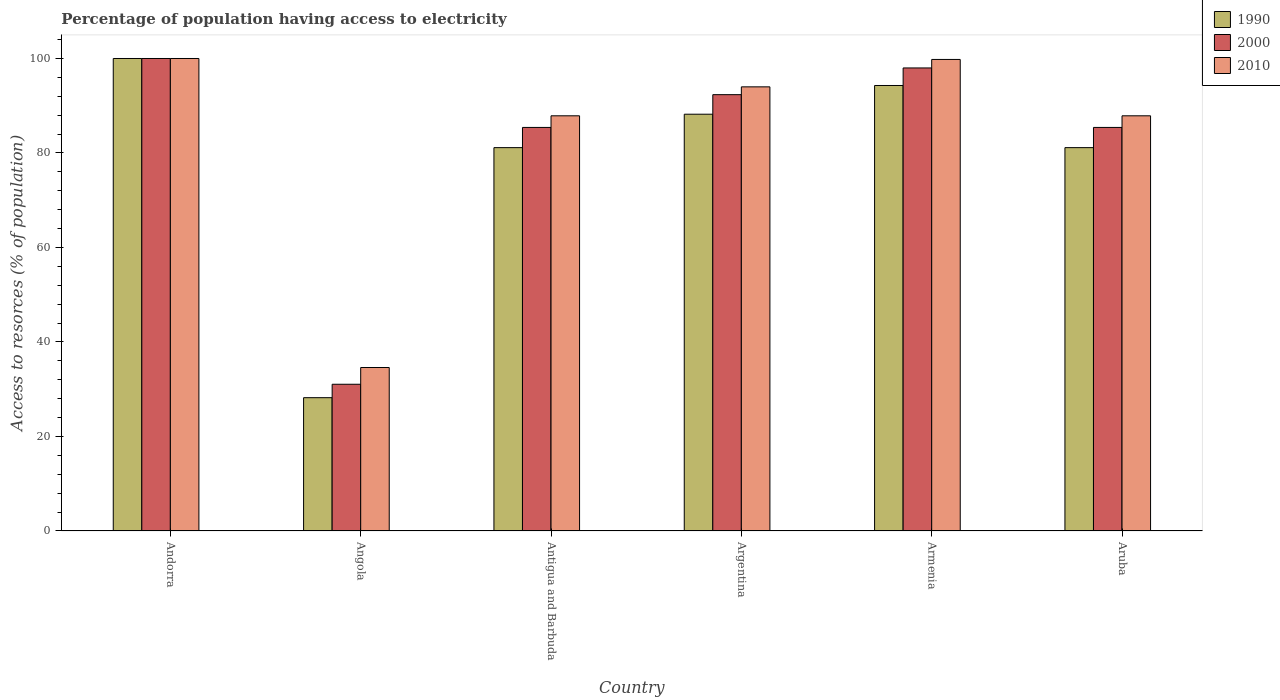How many different coloured bars are there?
Make the answer very short. 3. Are the number of bars per tick equal to the number of legend labels?
Offer a very short reply. Yes. Are the number of bars on each tick of the X-axis equal?
Provide a short and direct response. Yes. How many bars are there on the 2nd tick from the left?
Provide a short and direct response. 3. What is the label of the 5th group of bars from the left?
Give a very brief answer. Armenia. In how many cases, is the number of bars for a given country not equal to the number of legend labels?
Provide a short and direct response. 0. What is the percentage of population having access to electricity in 2000 in Aruba?
Your answer should be compact. 85.41. Across all countries, what is the minimum percentage of population having access to electricity in 2000?
Make the answer very short. 31.06. In which country was the percentage of population having access to electricity in 1990 maximum?
Provide a succinct answer. Andorra. In which country was the percentage of population having access to electricity in 2010 minimum?
Your answer should be compact. Angola. What is the total percentage of population having access to electricity in 2010 in the graph?
Keep it short and to the point. 504.15. What is the difference between the percentage of population having access to electricity in 2010 in Angola and that in Aruba?
Provide a succinct answer. -53.27. What is the difference between the percentage of population having access to electricity in 2010 in Andorra and the percentage of population having access to electricity in 1990 in Argentina?
Offer a very short reply. 11.79. What is the average percentage of population having access to electricity in 2000 per country?
Give a very brief answer. 82.04. What is the difference between the percentage of population having access to electricity of/in 2000 and percentage of population having access to electricity of/in 1990 in Argentina?
Your answer should be very brief. 4.14. What is the ratio of the percentage of population having access to electricity in 2000 in Armenia to that in Aruba?
Provide a succinct answer. 1.15. Is the percentage of population having access to electricity in 1990 in Angola less than that in Argentina?
Keep it short and to the point. Yes. Is the difference between the percentage of population having access to electricity in 2000 in Antigua and Barbuda and Aruba greater than the difference between the percentage of population having access to electricity in 1990 in Antigua and Barbuda and Aruba?
Give a very brief answer. No. What is the difference between the highest and the second highest percentage of population having access to electricity in 1990?
Offer a terse response. -11.79. What is the difference between the highest and the lowest percentage of population having access to electricity in 1990?
Keep it short and to the point. 71.78. What does the 1st bar from the left in Aruba represents?
Give a very brief answer. 1990. What does the 1st bar from the right in Argentina represents?
Keep it short and to the point. 2010. Is it the case that in every country, the sum of the percentage of population having access to electricity in 2000 and percentage of population having access to electricity in 1990 is greater than the percentage of population having access to electricity in 2010?
Provide a short and direct response. Yes. How many bars are there?
Give a very brief answer. 18. Does the graph contain any zero values?
Your response must be concise. No. Does the graph contain grids?
Provide a short and direct response. No. How many legend labels are there?
Offer a very short reply. 3. How are the legend labels stacked?
Give a very brief answer. Vertical. What is the title of the graph?
Provide a short and direct response. Percentage of population having access to electricity. What is the label or title of the Y-axis?
Offer a very short reply. Access to resorces (% of population). What is the Access to resorces (% of population) of 1990 in Angola?
Offer a very short reply. 28.22. What is the Access to resorces (% of population) of 2000 in Angola?
Provide a succinct answer. 31.06. What is the Access to resorces (% of population) in 2010 in Angola?
Ensure brevity in your answer.  34.6. What is the Access to resorces (% of population) of 1990 in Antigua and Barbuda?
Provide a succinct answer. 81.14. What is the Access to resorces (% of population) in 2000 in Antigua and Barbuda?
Provide a short and direct response. 85.41. What is the Access to resorces (% of population) of 2010 in Antigua and Barbuda?
Your response must be concise. 87.87. What is the Access to resorces (% of population) of 1990 in Argentina?
Provide a short and direct response. 88.21. What is the Access to resorces (% of population) in 2000 in Argentina?
Make the answer very short. 92.35. What is the Access to resorces (% of population) of 2010 in Argentina?
Your answer should be compact. 94. What is the Access to resorces (% of population) of 1990 in Armenia?
Make the answer very short. 94.29. What is the Access to resorces (% of population) in 2000 in Armenia?
Make the answer very short. 98. What is the Access to resorces (% of population) of 2010 in Armenia?
Provide a short and direct response. 99.8. What is the Access to resorces (% of population) of 1990 in Aruba?
Your answer should be compact. 81.14. What is the Access to resorces (% of population) of 2000 in Aruba?
Make the answer very short. 85.41. What is the Access to resorces (% of population) of 2010 in Aruba?
Provide a succinct answer. 87.87. Across all countries, what is the maximum Access to resorces (% of population) in 2000?
Offer a very short reply. 100. Across all countries, what is the minimum Access to resorces (% of population) in 1990?
Provide a short and direct response. 28.22. Across all countries, what is the minimum Access to resorces (% of population) in 2000?
Your answer should be very brief. 31.06. Across all countries, what is the minimum Access to resorces (% of population) of 2010?
Your response must be concise. 34.6. What is the total Access to resorces (% of population) in 1990 in the graph?
Give a very brief answer. 472.98. What is the total Access to resorces (% of population) in 2000 in the graph?
Offer a terse response. 492.23. What is the total Access to resorces (% of population) in 2010 in the graph?
Provide a short and direct response. 504.15. What is the difference between the Access to resorces (% of population) of 1990 in Andorra and that in Angola?
Give a very brief answer. 71.78. What is the difference between the Access to resorces (% of population) of 2000 in Andorra and that in Angola?
Make the answer very short. 68.94. What is the difference between the Access to resorces (% of population) in 2010 in Andorra and that in Angola?
Make the answer very short. 65.4. What is the difference between the Access to resorces (% of population) in 1990 in Andorra and that in Antigua and Barbuda?
Your answer should be very brief. 18.86. What is the difference between the Access to resorces (% of population) of 2000 in Andorra and that in Antigua and Barbuda?
Ensure brevity in your answer.  14.59. What is the difference between the Access to resorces (% of population) of 2010 in Andorra and that in Antigua and Barbuda?
Your response must be concise. 12.13. What is the difference between the Access to resorces (% of population) in 1990 in Andorra and that in Argentina?
Offer a terse response. 11.79. What is the difference between the Access to resorces (% of population) of 2000 in Andorra and that in Argentina?
Give a very brief answer. 7.65. What is the difference between the Access to resorces (% of population) of 1990 in Andorra and that in Armenia?
Provide a short and direct response. 5.71. What is the difference between the Access to resorces (% of population) in 2000 in Andorra and that in Armenia?
Ensure brevity in your answer.  2. What is the difference between the Access to resorces (% of population) of 2010 in Andorra and that in Armenia?
Your answer should be compact. 0.2. What is the difference between the Access to resorces (% of population) in 1990 in Andorra and that in Aruba?
Your answer should be compact. 18.86. What is the difference between the Access to resorces (% of population) of 2000 in Andorra and that in Aruba?
Provide a short and direct response. 14.59. What is the difference between the Access to resorces (% of population) in 2010 in Andorra and that in Aruba?
Keep it short and to the point. 12.13. What is the difference between the Access to resorces (% of population) in 1990 in Angola and that in Antigua and Barbuda?
Make the answer very short. -52.92. What is the difference between the Access to resorces (% of population) in 2000 in Angola and that in Antigua and Barbuda?
Ensure brevity in your answer.  -54.36. What is the difference between the Access to resorces (% of population) in 2010 in Angola and that in Antigua and Barbuda?
Ensure brevity in your answer.  -53.27. What is the difference between the Access to resorces (% of population) of 1990 in Angola and that in Argentina?
Provide a succinct answer. -59.99. What is the difference between the Access to resorces (% of population) in 2000 in Angola and that in Argentina?
Your response must be concise. -61.29. What is the difference between the Access to resorces (% of population) in 2010 in Angola and that in Argentina?
Give a very brief answer. -59.4. What is the difference between the Access to resorces (% of population) of 1990 in Angola and that in Armenia?
Your answer should be very brief. -66.07. What is the difference between the Access to resorces (% of population) of 2000 in Angola and that in Armenia?
Your answer should be compact. -66.94. What is the difference between the Access to resorces (% of population) of 2010 in Angola and that in Armenia?
Your response must be concise. -65.2. What is the difference between the Access to resorces (% of population) of 1990 in Angola and that in Aruba?
Your response must be concise. -52.92. What is the difference between the Access to resorces (% of population) of 2000 in Angola and that in Aruba?
Ensure brevity in your answer.  -54.36. What is the difference between the Access to resorces (% of population) of 2010 in Angola and that in Aruba?
Your answer should be very brief. -53.27. What is the difference between the Access to resorces (% of population) of 1990 in Antigua and Barbuda and that in Argentina?
Offer a terse response. -7.07. What is the difference between the Access to resorces (% of population) of 2000 in Antigua and Barbuda and that in Argentina?
Make the answer very short. -6.94. What is the difference between the Access to resorces (% of population) of 2010 in Antigua and Barbuda and that in Argentina?
Keep it short and to the point. -6.13. What is the difference between the Access to resorces (% of population) in 1990 in Antigua and Barbuda and that in Armenia?
Your answer should be very brief. -13.15. What is the difference between the Access to resorces (% of population) in 2000 in Antigua and Barbuda and that in Armenia?
Offer a terse response. -12.59. What is the difference between the Access to resorces (% of population) of 2010 in Antigua and Barbuda and that in Armenia?
Offer a very short reply. -11.93. What is the difference between the Access to resorces (% of population) in 2000 in Antigua and Barbuda and that in Aruba?
Ensure brevity in your answer.  0. What is the difference between the Access to resorces (% of population) of 1990 in Argentina and that in Armenia?
Your response must be concise. -6.08. What is the difference between the Access to resorces (% of population) of 2000 in Argentina and that in Armenia?
Offer a terse response. -5.65. What is the difference between the Access to resorces (% of population) in 2010 in Argentina and that in Armenia?
Your answer should be compact. -5.8. What is the difference between the Access to resorces (% of population) of 1990 in Argentina and that in Aruba?
Your response must be concise. 7.07. What is the difference between the Access to resorces (% of population) in 2000 in Argentina and that in Aruba?
Your answer should be very brief. 6.94. What is the difference between the Access to resorces (% of population) in 2010 in Argentina and that in Aruba?
Offer a very short reply. 6.13. What is the difference between the Access to resorces (% of population) of 1990 in Armenia and that in Aruba?
Provide a succinct answer. 13.15. What is the difference between the Access to resorces (% of population) in 2000 in Armenia and that in Aruba?
Offer a very short reply. 12.59. What is the difference between the Access to resorces (% of population) of 2010 in Armenia and that in Aruba?
Your answer should be very brief. 11.93. What is the difference between the Access to resorces (% of population) of 1990 in Andorra and the Access to resorces (% of population) of 2000 in Angola?
Keep it short and to the point. 68.94. What is the difference between the Access to resorces (% of population) in 1990 in Andorra and the Access to resorces (% of population) in 2010 in Angola?
Give a very brief answer. 65.4. What is the difference between the Access to resorces (% of population) in 2000 in Andorra and the Access to resorces (% of population) in 2010 in Angola?
Provide a succinct answer. 65.4. What is the difference between the Access to resorces (% of population) in 1990 in Andorra and the Access to resorces (% of population) in 2000 in Antigua and Barbuda?
Keep it short and to the point. 14.59. What is the difference between the Access to resorces (% of population) in 1990 in Andorra and the Access to resorces (% of population) in 2010 in Antigua and Barbuda?
Offer a terse response. 12.13. What is the difference between the Access to resorces (% of population) in 2000 in Andorra and the Access to resorces (% of population) in 2010 in Antigua and Barbuda?
Offer a terse response. 12.13. What is the difference between the Access to resorces (% of population) of 1990 in Andorra and the Access to resorces (% of population) of 2000 in Argentina?
Give a very brief answer. 7.65. What is the difference between the Access to resorces (% of population) of 1990 in Andorra and the Access to resorces (% of population) of 2010 in Argentina?
Your answer should be compact. 6. What is the difference between the Access to resorces (% of population) of 1990 in Andorra and the Access to resorces (% of population) of 2000 in Armenia?
Your answer should be compact. 2. What is the difference between the Access to resorces (% of population) of 1990 in Andorra and the Access to resorces (% of population) of 2010 in Armenia?
Keep it short and to the point. 0.2. What is the difference between the Access to resorces (% of population) of 2000 in Andorra and the Access to resorces (% of population) of 2010 in Armenia?
Keep it short and to the point. 0.2. What is the difference between the Access to resorces (% of population) of 1990 in Andorra and the Access to resorces (% of population) of 2000 in Aruba?
Your answer should be very brief. 14.59. What is the difference between the Access to resorces (% of population) in 1990 in Andorra and the Access to resorces (% of population) in 2010 in Aruba?
Your answer should be very brief. 12.13. What is the difference between the Access to resorces (% of population) of 2000 in Andorra and the Access to resorces (% of population) of 2010 in Aruba?
Give a very brief answer. 12.13. What is the difference between the Access to resorces (% of population) in 1990 in Angola and the Access to resorces (% of population) in 2000 in Antigua and Barbuda?
Give a very brief answer. -57.2. What is the difference between the Access to resorces (% of population) in 1990 in Angola and the Access to resorces (% of population) in 2010 in Antigua and Barbuda?
Provide a short and direct response. -59.66. What is the difference between the Access to resorces (% of population) in 2000 in Angola and the Access to resorces (% of population) in 2010 in Antigua and Barbuda?
Offer a very short reply. -56.82. What is the difference between the Access to resorces (% of population) in 1990 in Angola and the Access to resorces (% of population) in 2000 in Argentina?
Provide a short and direct response. -64.13. What is the difference between the Access to resorces (% of population) of 1990 in Angola and the Access to resorces (% of population) of 2010 in Argentina?
Your answer should be very brief. -65.78. What is the difference between the Access to resorces (% of population) of 2000 in Angola and the Access to resorces (% of population) of 2010 in Argentina?
Your answer should be very brief. -62.94. What is the difference between the Access to resorces (% of population) in 1990 in Angola and the Access to resorces (% of population) in 2000 in Armenia?
Keep it short and to the point. -69.78. What is the difference between the Access to resorces (% of population) of 1990 in Angola and the Access to resorces (% of population) of 2010 in Armenia?
Make the answer very short. -71.58. What is the difference between the Access to resorces (% of population) of 2000 in Angola and the Access to resorces (% of population) of 2010 in Armenia?
Provide a short and direct response. -68.74. What is the difference between the Access to resorces (% of population) in 1990 in Angola and the Access to resorces (% of population) in 2000 in Aruba?
Provide a succinct answer. -57.2. What is the difference between the Access to resorces (% of population) in 1990 in Angola and the Access to resorces (% of population) in 2010 in Aruba?
Your answer should be very brief. -59.66. What is the difference between the Access to resorces (% of population) of 2000 in Angola and the Access to resorces (% of population) of 2010 in Aruba?
Make the answer very short. -56.82. What is the difference between the Access to resorces (% of population) in 1990 in Antigua and Barbuda and the Access to resorces (% of population) in 2000 in Argentina?
Keep it short and to the point. -11.21. What is the difference between the Access to resorces (% of population) of 1990 in Antigua and Barbuda and the Access to resorces (% of population) of 2010 in Argentina?
Offer a terse response. -12.86. What is the difference between the Access to resorces (% of population) in 2000 in Antigua and Barbuda and the Access to resorces (% of population) in 2010 in Argentina?
Your response must be concise. -8.59. What is the difference between the Access to resorces (% of population) in 1990 in Antigua and Barbuda and the Access to resorces (% of population) in 2000 in Armenia?
Give a very brief answer. -16.86. What is the difference between the Access to resorces (% of population) in 1990 in Antigua and Barbuda and the Access to resorces (% of population) in 2010 in Armenia?
Your answer should be very brief. -18.66. What is the difference between the Access to resorces (% of population) of 2000 in Antigua and Barbuda and the Access to resorces (% of population) of 2010 in Armenia?
Make the answer very short. -14.39. What is the difference between the Access to resorces (% of population) in 1990 in Antigua and Barbuda and the Access to resorces (% of population) in 2000 in Aruba?
Offer a very short reply. -4.28. What is the difference between the Access to resorces (% of population) in 1990 in Antigua and Barbuda and the Access to resorces (% of population) in 2010 in Aruba?
Your answer should be compact. -6.74. What is the difference between the Access to resorces (% of population) in 2000 in Antigua and Barbuda and the Access to resorces (% of population) in 2010 in Aruba?
Give a very brief answer. -2.46. What is the difference between the Access to resorces (% of population) of 1990 in Argentina and the Access to resorces (% of population) of 2000 in Armenia?
Offer a terse response. -9.79. What is the difference between the Access to resorces (% of population) in 1990 in Argentina and the Access to resorces (% of population) in 2010 in Armenia?
Make the answer very short. -11.59. What is the difference between the Access to resorces (% of population) in 2000 in Argentina and the Access to resorces (% of population) in 2010 in Armenia?
Ensure brevity in your answer.  -7.45. What is the difference between the Access to resorces (% of population) in 1990 in Argentina and the Access to resorces (% of population) in 2000 in Aruba?
Make the answer very short. 2.8. What is the difference between the Access to resorces (% of population) in 1990 in Argentina and the Access to resorces (% of population) in 2010 in Aruba?
Ensure brevity in your answer.  0.33. What is the difference between the Access to resorces (% of population) in 2000 in Argentina and the Access to resorces (% of population) in 2010 in Aruba?
Offer a terse response. 4.47. What is the difference between the Access to resorces (% of population) in 1990 in Armenia and the Access to resorces (% of population) in 2000 in Aruba?
Your response must be concise. 8.88. What is the difference between the Access to resorces (% of population) in 1990 in Armenia and the Access to resorces (% of population) in 2010 in Aruba?
Your answer should be very brief. 6.41. What is the difference between the Access to resorces (% of population) of 2000 in Armenia and the Access to resorces (% of population) of 2010 in Aruba?
Your response must be concise. 10.13. What is the average Access to resorces (% of population) in 1990 per country?
Your answer should be compact. 78.83. What is the average Access to resorces (% of population) in 2000 per country?
Make the answer very short. 82.04. What is the average Access to resorces (% of population) of 2010 per country?
Your answer should be compact. 84.02. What is the difference between the Access to resorces (% of population) of 1990 and Access to resorces (% of population) of 2000 in Andorra?
Provide a short and direct response. 0. What is the difference between the Access to resorces (% of population) in 1990 and Access to resorces (% of population) in 2000 in Angola?
Your response must be concise. -2.84. What is the difference between the Access to resorces (% of population) in 1990 and Access to resorces (% of population) in 2010 in Angola?
Offer a very short reply. -6.38. What is the difference between the Access to resorces (% of population) of 2000 and Access to resorces (% of population) of 2010 in Angola?
Offer a terse response. -3.54. What is the difference between the Access to resorces (% of population) of 1990 and Access to resorces (% of population) of 2000 in Antigua and Barbuda?
Offer a very short reply. -4.28. What is the difference between the Access to resorces (% of population) in 1990 and Access to resorces (% of population) in 2010 in Antigua and Barbuda?
Ensure brevity in your answer.  -6.74. What is the difference between the Access to resorces (% of population) in 2000 and Access to resorces (% of population) in 2010 in Antigua and Barbuda?
Make the answer very short. -2.46. What is the difference between the Access to resorces (% of population) in 1990 and Access to resorces (% of population) in 2000 in Argentina?
Ensure brevity in your answer.  -4.14. What is the difference between the Access to resorces (% of population) of 1990 and Access to resorces (% of population) of 2010 in Argentina?
Give a very brief answer. -5.79. What is the difference between the Access to resorces (% of population) of 2000 and Access to resorces (% of population) of 2010 in Argentina?
Give a very brief answer. -1.65. What is the difference between the Access to resorces (% of population) of 1990 and Access to resorces (% of population) of 2000 in Armenia?
Ensure brevity in your answer.  -3.71. What is the difference between the Access to resorces (% of population) of 1990 and Access to resorces (% of population) of 2010 in Armenia?
Your answer should be compact. -5.51. What is the difference between the Access to resorces (% of population) in 2000 and Access to resorces (% of population) in 2010 in Armenia?
Provide a short and direct response. -1.8. What is the difference between the Access to resorces (% of population) in 1990 and Access to resorces (% of population) in 2000 in Aruba?
Ensure brevity in your answer.  -4.28. What is the difference between the Access to resorces (% of population) of 1990 and Access to resorces (% of population) of 2010 in Aruba?
Ensure brevity in your answer.  -6.74. What is the difference between the Access to resorces (% of population) of 2000 and Access to resorces (% of population) of 2010 in Aruba?
Offer a very short reply. -2.46. What is the ratio of the Access to resorces (% of population) in 1990 in Andorra to that in Angola?
Ensure brevity in your answer.  3.54. What is the ratio of the Access to resorces (% of population) of 2000 in Andorra to that in Angola?
Provide a short and direct response. 3.22. What is the ratio of the Access to resorces (% of population) of 2010 in Andorra to that in Angola?
Your answer should be very brief. 2.89. What is the ratio of the Access to resorces (% of population) in 1990 in Andorra to that in Antigua and Barbuda?
Provide a short and direct response. 1.23. What is the ratio of the Access to resorces (% of population) in 2000 in Andorra to that in Antigua and Barbuda?
Keep it short and to the point. 1.17. What is the ratio of the Access to resorces (% of population) of 2010 in Andorra to that in Antigua and Barbuda?
Your answer should be compact. 1.14. What is the ratio of the Access to resorces (% of population) in 1990 in Andorra to that in Argentina?
Provide a succinct answer. 1.13. What is the ratio of the Access to resorces (% of population) of 2000 in Andorra to that in Argentina?
Offer a very short reply. 1.08. What is the ratio of the Access to resorces (% of population) in 2010 in Andorra to that in Argentina?
Keep it short and to the point. 1.06. What is the ratio of the Access to resorces (% of population) in 1990 in Andorra to that in Armenia?
Make the answer very short. 1.06. What is the ratio of the Access to resorces (% of population) of 2000 in Andorra to that in Armenia?
Keep it short and to the point. 1.02. What is the ratio of the Access to resorces (% of population) of 2010 in Andorra to that in Armenia?
Provide a short and direct response. 1. What is the ratio of the Access to resorces (% of population) in 1990 in Andorra to that in Aruba?
Ensure brevity in your answer.  1.23. What is the ratio of the Access to resorces (% of population) of 2000 in Andorra to that in Aruba?
Offer a terse response. 1.17. What is the ratio of the Access to resorces (% of population) in 2010 in Andorra to that in Aruba?
Give a very brief answer. 1.14. What is the ratio of the Access to resorces (% of population) in 1990 in Angola to that in Antigua and Barbuda?
Your answer should be compact. 0.35. What is the ratio of the Access to resorces (% of population) of 2000 in Angola to that in Antigua and Barbuda?
Make the answer very short. 0.36. What is the ratio of the Access to resorces (% of population) in 2010 in Angola to that in Antigua and Barbuda?
Make the answer very short. 0.39. What is the ratio of the Access to resorces (% of population) of 1990 in Angola to that in Argentina?
Offer a very short reply. 0.32. What is the ratio of the Access to resorces (% of population) of 2000 in Angola to that in Argentina?
Provide a succinct answer. 0.34. What is the ratio of the Access to resorces (% of population) of 2010 in Angola to that in Argentina?
Keep it short and to the point. 0.37. What is the ratio of the Access to resorces (% of population) of 1990 in Angola to that in Armenia?
Give a very brief answer. 0.3. What is the ratio of the Access to resorces (% of population) in 2000 in Angola to that in Armenia?
Offer a very short reply. 0.32. What is the ratio of the Access to resorces (% of population) in 2010 in Angola to that in Armenia?
Provide a succinct answer. 0.35. What is the ratio of the Access to resorces (% of population) of 1990 in Angola to that in Aruba?
Your answer should be very brief. 0.35. What is the ratio of the Access to resorces (% of population) of 2000 in Angola to that in Aruba?
Provide a short and direct response. 0.36. What is the ratio of the Access to resorces (% of population) in 2010 in Angola to that in Aruba?
Your answer should be compact. 0.39. What is the ratio of the Access to resorces (% of population) in 1990 in Antigua and Barbuda to that in Argentina?
Ensure brevity in your answer.  0.92. What is the ratio of the Access to resorces (% of population) in 2000 in Antigua and Barbuda to that in Argentina?
Your answer should be compact. 0.92. What is the ratio of the Access to resorces (% of population) of 2010 in Antigua and Barbuda to that in Argentina?
Your answer should be compact. 0.93. What is the ratio of the Access to resorces (% of population) in 1990 in Antigua and Barbuda to that in Armenia?
Offer a very short reply. 0.86. What is the ratio of the Access to resorces (% of population) in 2000 in Antigua and Barbuda to that in Armenia?
Ensure brevity in your answer.  0.87. What is the ratio of the Access to resorces (% of population) of 2010 in Antigua and Barbuda to that in Armenia?
Ensure brevity in your answer.  0.88. What is the ratio of the Access to resorces (% of population) in 1990 in Antigua and Barbuda to that in Aruba?
Your response must be concise. 1. What is the ratio of the Access to resorces (% of population) of 1990 in Argentina to that in Armenia?
Offer a terse response. 0.94. What is the ratio of the Access to resorces (% of population) of 2000 in Argentina to that in Armenia?
Make the answer very short. 0.94. What is the ratio of the Access to resorces (% of population) in 2010 in Argentina to that in Armenia?
Provide a succinct answer. 0.94. What is the ratio of the Access to resorces (% of population) in 1990 in Argentina to that in Aruba?
Offer a terse response. 1.09. What is the ratio of the Access to resorces (% of population) of 2000 in Argentina to that in Aruba?
Your response must be concise. 1.08. What is the ratio of the Access to resorces (% of population) in 2010 in Argentina to that in Aruba?
Your response must be concise. 1.07. What is the ratio of the Access to resorces (% of population) of 1990 in Armenia to that in Aruba?
Provide a succinct answer. 1.16. What is the ratio of the Access to resorces (% of population) in 2000 in Armenia to that in Aruba?
Keep it short and to the point. 1.15. What is the ratio of the Access to resorces (% of population) in 2010 in Armenia to that in Aruba?
Ensure brevity in your answer.  1.14. What is the difference between the highest and the second highest Access to resorces (% of population) in 1990?
Give a very brief answer. 5.71. What is the difference between the highest and the second highest Access to resorces (% of population) of 2000?
Provide a succinct answer. 2. What is the difference between the highest and the second highest Access to resorces (% of population) in 2010?
Ensure brevity in your answer.  0.2. What is the difference between the highest and the lowest Access to resorces (% of population) of 1990?
Your answer should be compact. 71.78. What is the difference between the highest and the lowest Access to resorces (% of population) in 2000?
Your answer should be very brief. 68.94. What is the difference between the highest and the lowest Access to resorces (% of population) of 2010?
Provide a succinct answer. 65.4. 